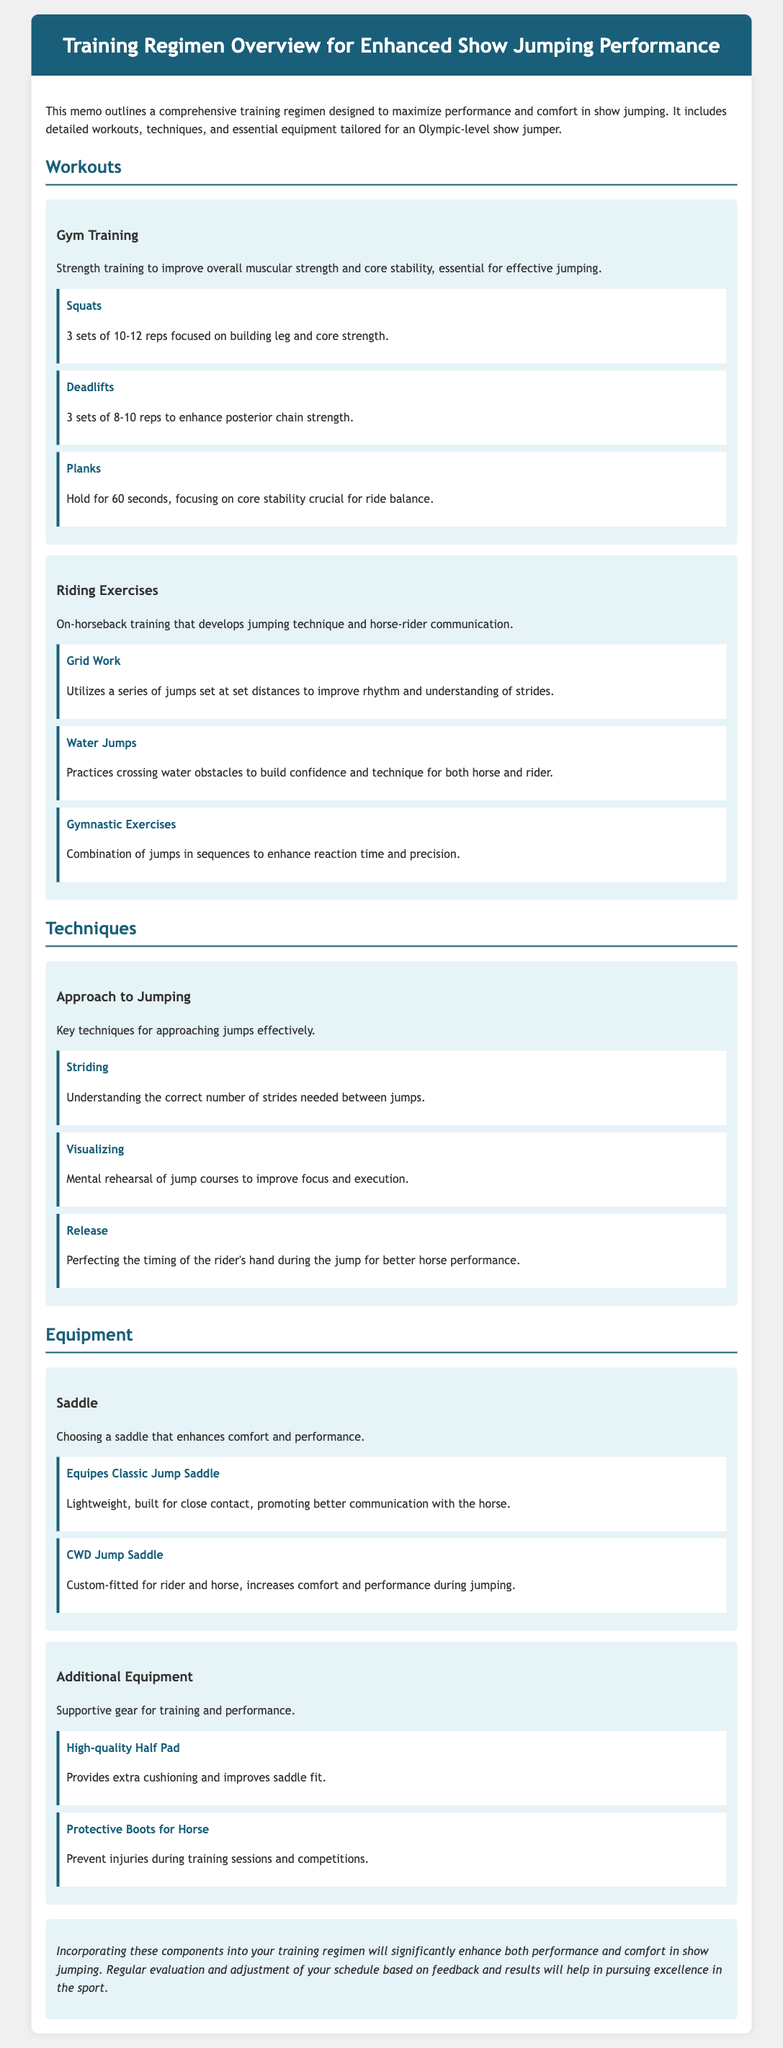What is the primary goal of the training regimen? The memo states that the training regimen is designed to maximize performance and comfort in show jumping.
Answer: maximize performance and comfort How many sets are recommended for squats? The document specifies 3 sets of 10-12 reps for squats.
Answer: 3 sets What equipment is specifically mentioned for saddle choice? The memo outlines two specific saddles for performance enhancement.
Answer: Equipes Classic Jump Saddle, CWD Jump Saddle What type of training utilizes water jumps? The document discusses a specific type of riding exercise that develops confidence in both horse and rider.
Answer: Riding Exercises Which exercise focuses on core stability? The memo lists exercises in gym training, one of which is specifically aimed at core stability.
Answer: Planks What technique is used for mental rehearsal of jump courses? The document defines a technique that involves imagining jump courses to improve focus.
Answer: Visualizing How long should planks be held? The document specifies a duration for holding planks.
Answer: 60 seconds What type of additional equipment improves saddle fit? The memo mentions supportive gear that provides extra cushioning for the saddle.
Answer: High-quality Half Pad 